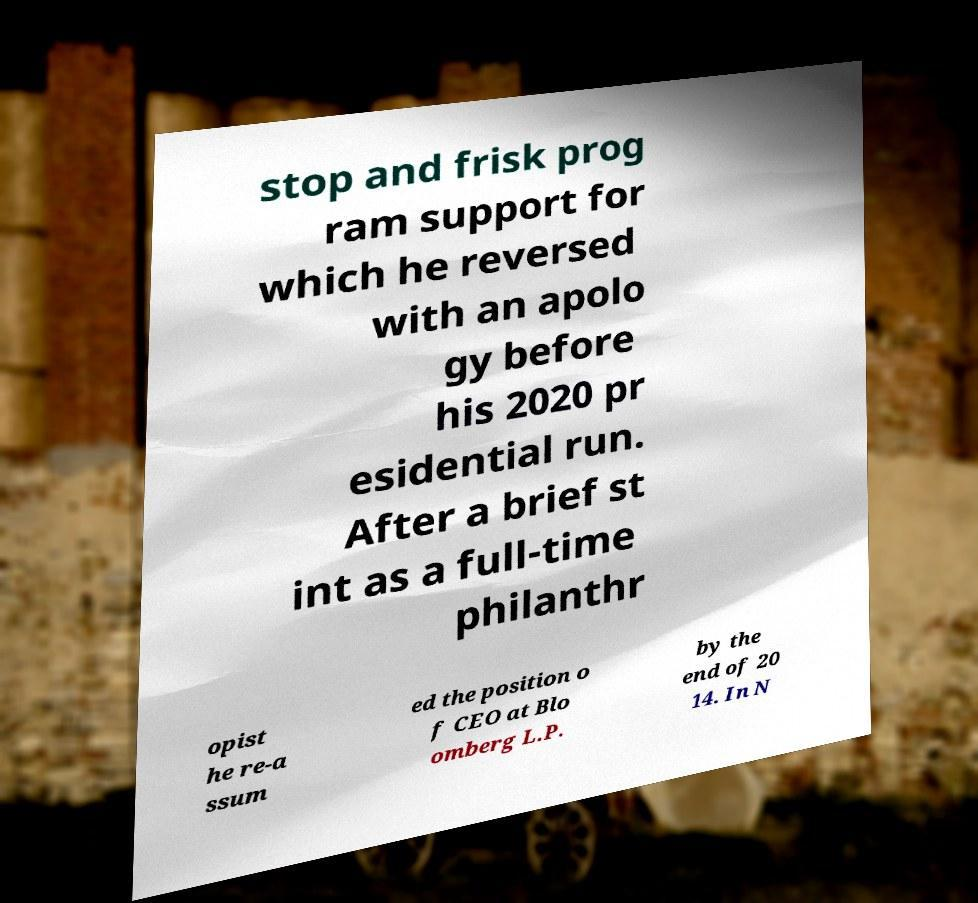Please read and relay the text visible in this image. What does it say? stop and frisk prog ram support for which he reversed with an apolo gy before his 2020 pr esidential run. After a brief st int as a full-time philanthr opist he re-a ssum ed the position o f CEO at Blo omberg L.P. by the end of 20 14. In N 